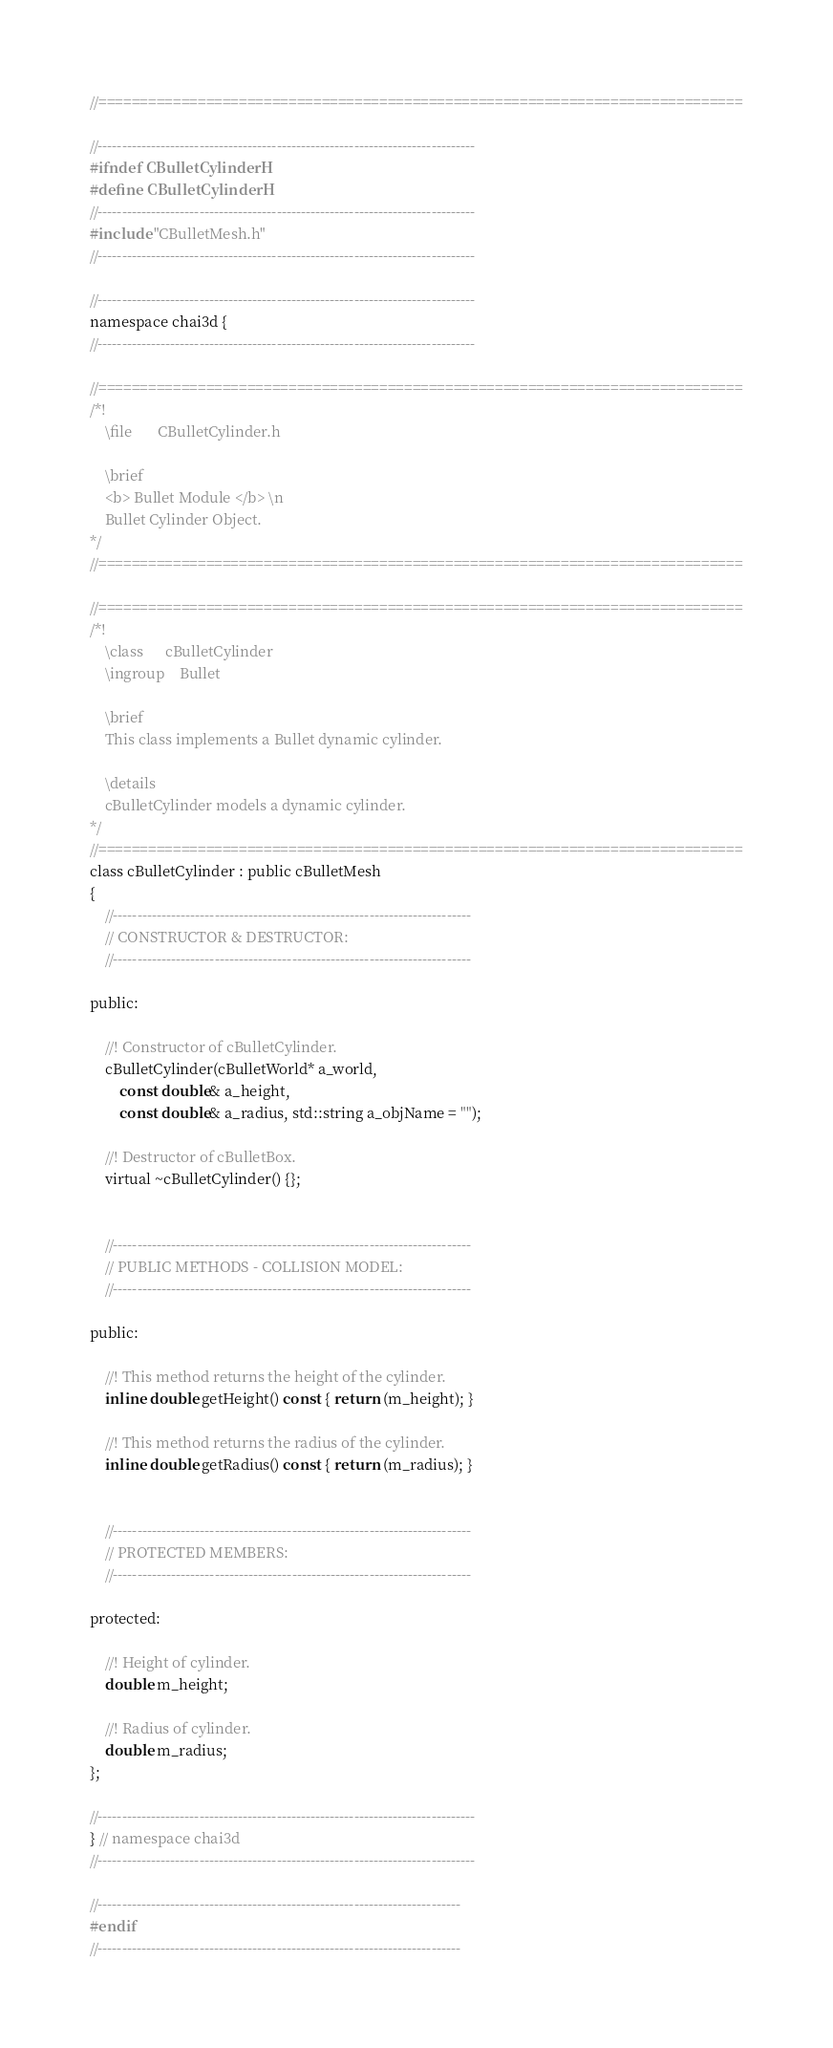Convert code to text. <code><loc_0><loc_0><loc_500><loc_500><_C_>//==============================================================================

//------------------------------------------------------------------------------
#ifndef CBulletCylinderH
#define CBulletCylinderH
//------------------------------------------------------------------------------
#include "CBulletMesh.h"
//------------------------------------------------------------------------------

//------------------------------------------------------------------------------
namespace chai3d {
//------------------------------------------------------------------------------

//==============================================================================
/*!
    \file       CBulletCylinder.h

    \brief
    <b> Bullet Module </b> \n 
    Bullet Cylinder Object.
*/
//==============================================================================

//==============================================================================
/*!
    \class      cBulletCylinder
    \ingroup    Bullet

    \brief
    This class implements a Bullet dynamic cylinder.

    \details
    cBulletCylinder models a dynamic cylinder.
*/
//==============================================================================
class cBulletCylinder : public cBulletMesh
{
    //--------------------------------------------------------------------------
    // CONSTRUCTOR & DESTRUCTOR:
    //--------------------------------------------------------------------------

public:

    //! Constructor of cBulletCylinder.
    cBulletCylinder(cBulletWorld* a_world,
        const double& a_height, 
        const double& a_radius, std::string a_objName = "");

    //! Destructor of cBulletBox.
    virtual ~cBulletCylinder() {};


    //--------------------------------------------------------------------------
    // PUBLIC METHODS - COLLISION MODEL:
    //--------------------------------------------------------------------------

public:

    //! This method returns the height of the cylinder.
    inline double getHeight() const { return (m_height); }

    //! This method returns the radius of the cylinder.
    inline double getRadius() const { return (m_radius); }


    //--------------------------------------------------------------------------
    // PROTECTED MEMBERS:
    //--------------------------------------------------------------------------

protected:

    //! Height of cylinder.
    double m_height;

    //! Radius of cylinder.
    double m_radius;
};

//------------------------------------------------------------------------------
} // namespace chai3d
//------------------------------------------------------------------------------

//---------------------------------------------------------------------------
#endif
//---------------------------------------------------------------------------
</code> 